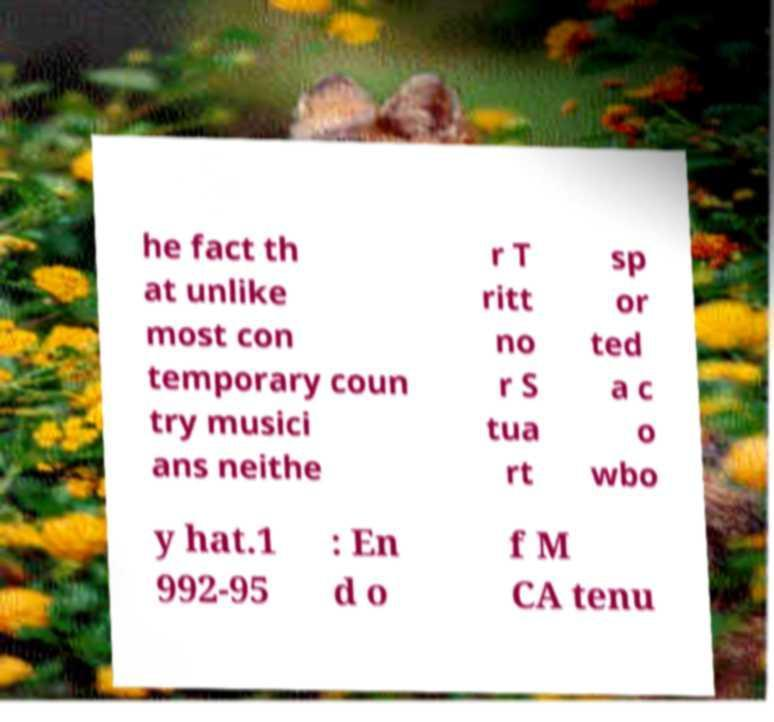For documentation purposes, I need the text within this image transcribed. Could you provide that? he fact th at unlike most con temporary coun try musici ans neithe r T ritt no r S tua rt sp or ted a c o wbo y hat.1 992-95 : En d o f M CA tenu 